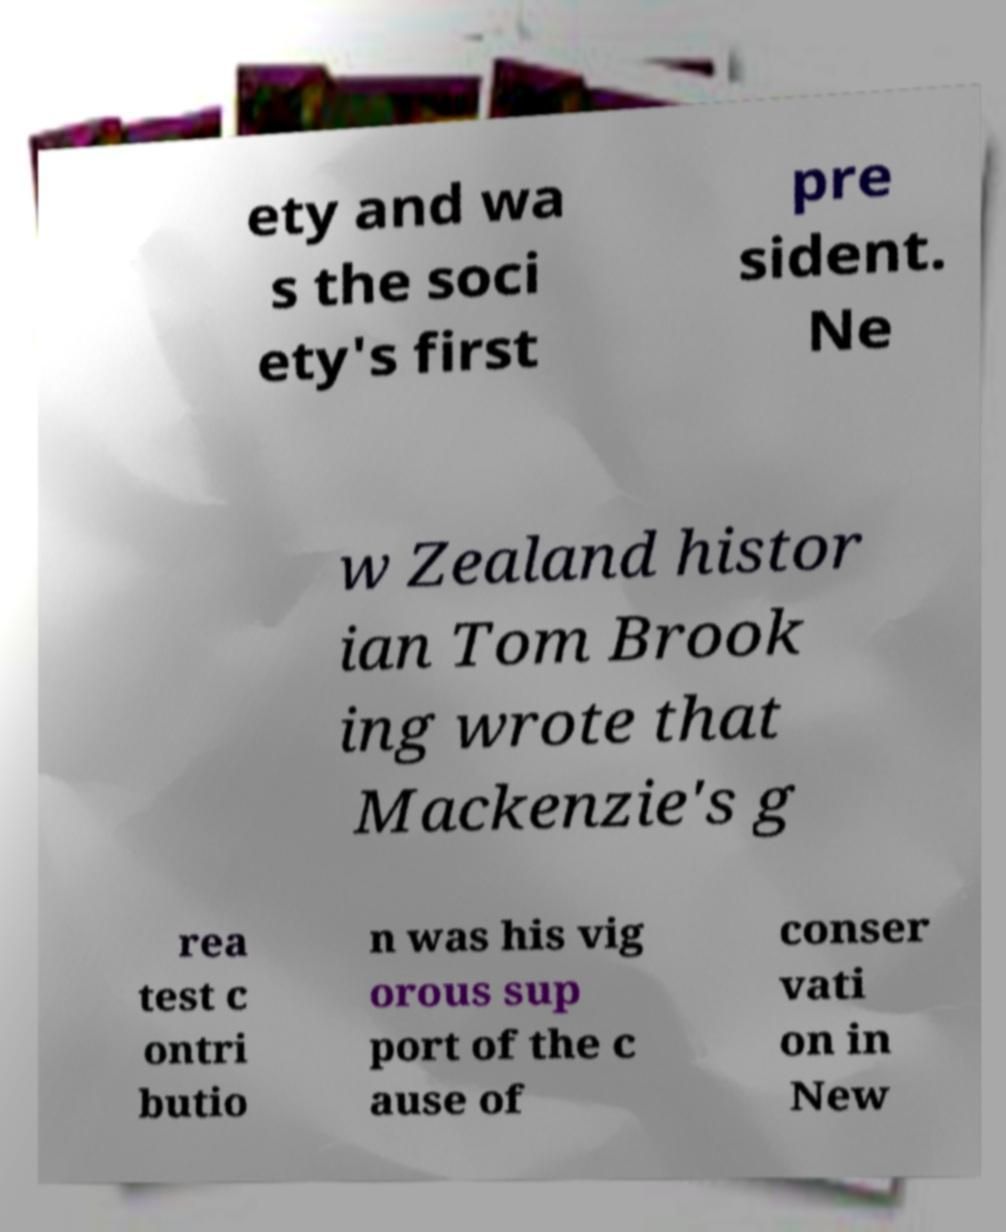Could you assist in decoding the text presented in this image and type it out clearly? ety and wa s the soci ety's first pre sident. Ne w Zealand histor ian Tom Brook ing wrote that Mackenzie's g rea test c ontri butio n was his vig orous sup port of the c ause of conser vati on in New 